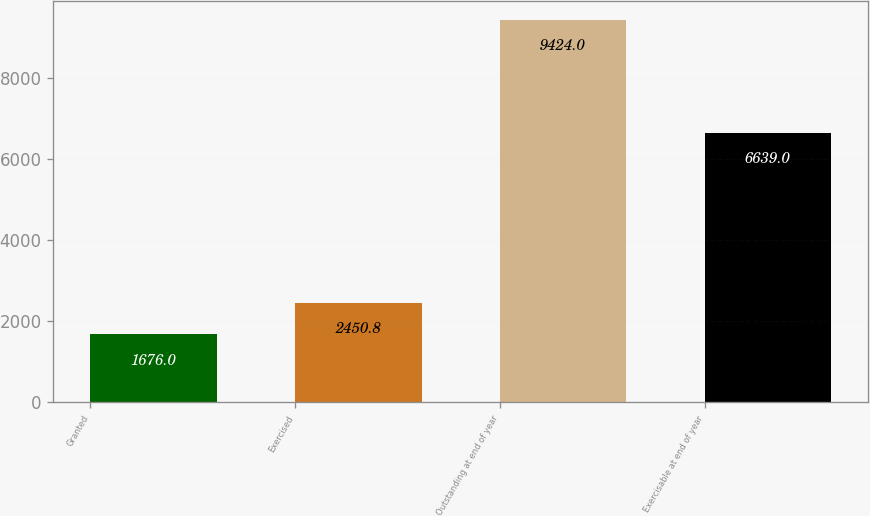<chart> <loc_0><loc_0><loc_500><loc_500><bar_chart><fcel>Granted<fcel>Exercised<fcel>Outstanding at end of year<fcel>Exercisable at end of year<nl><fcel>1676<fcel>2450.8<fcel>9424<fcel>6639<nl></chart> 